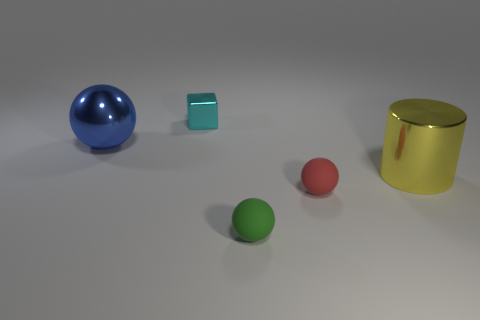There is a red sphere; is its size the same as the shiny object to the right of the green matte thing?
Your response must be concise. No. There is a tiny cyan object that is to the right of the object left of the cyan metal object; what is its shape?
Make the answer very short. Cube. Are there fewer shiny spheres to the right of the big blue metallic object than big cyan objects?
Your response must be concise. No. How many cyan objects are the same size as the red matte thing?
Keep it short and to the point. 1. What shape is the large shiny thing that is on the right side of the shiny ball?
Your answer should be compact. Cylinder. Are there fewer small red spheres than things?
Ensure brevity in your answer.  Yes. There is a thing behind the large metallic ball; what is its size?
Provide a short and direct response. Small. Is the number of blue spheres greater than the number of balls?
Provide a short and direct response. No. What is the yellow object made of?
Give a very brief answer. Metal. What number of other objects are the same material as the blue ball?
Offer a very short reply. 2. 